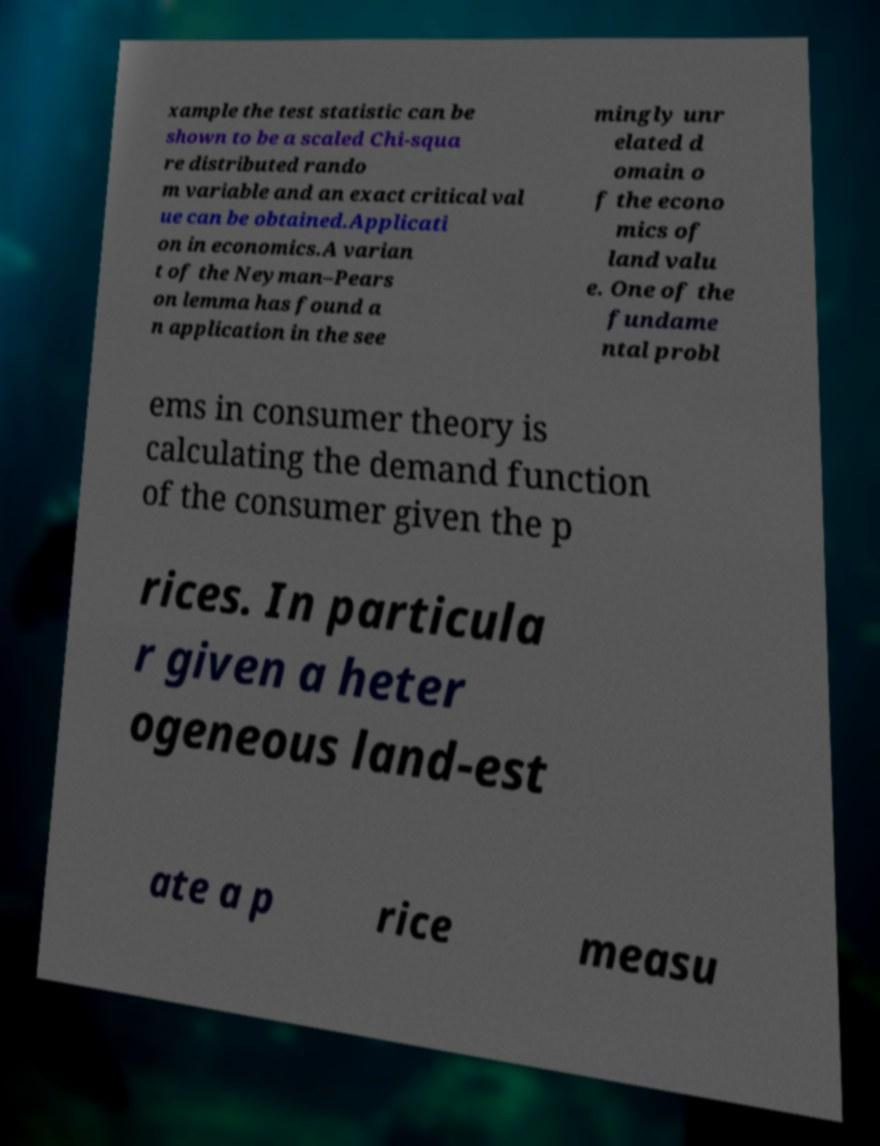I need the written content from this picture converted into text. Can you do that? xample the test statistic can be shown to be a scaled Chi-squa re distributed rando m variable and an exact critical val ue can be obtained.Applicati on in economics.A varian t of the Neyman–Pears on lemma has found a n application in the see mingly unr elated d omain o f the econo mics of land valu e. One of the fundame ntal probl ems in consumer theory is calculating the demand function of the consumer given the p rices. In particula r given a heter ogeneous land-est ate a p rice measu 